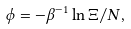<formula> <loc_0><loc_0><loc_500><loc_500>\phi = - \beta ^ { - 1 } \ln \Xi / N ,</formula> 